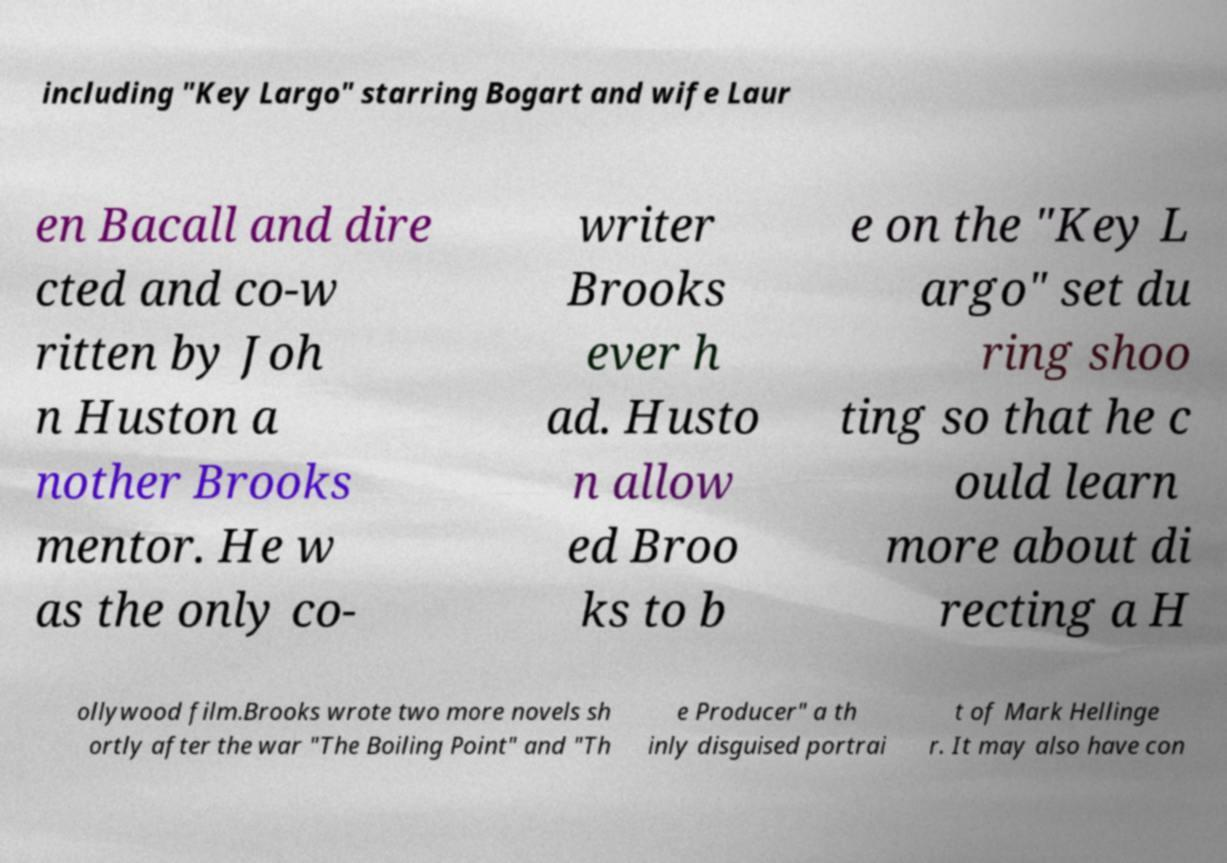Can you accurately transcribe the text from the provided image for me? including "Key Largo" starring Bogart and wife Laur en Bacall and dire cted and co-w ritten by Joh n Huston a nother Brooks mentor. He w as the only co- writer Brooks ever h ad. Husto n allow ed Broo ks to b e on the "Key L argo" set du ring shoo ting so that he c ould learn more about di recting a H ollywood film.Brooks wrote two more novels sh ortly after the war "The Boiling Point" and "Th e Producer" a th inly disguised portrai t of Mark Hellinge r. It may also have con 